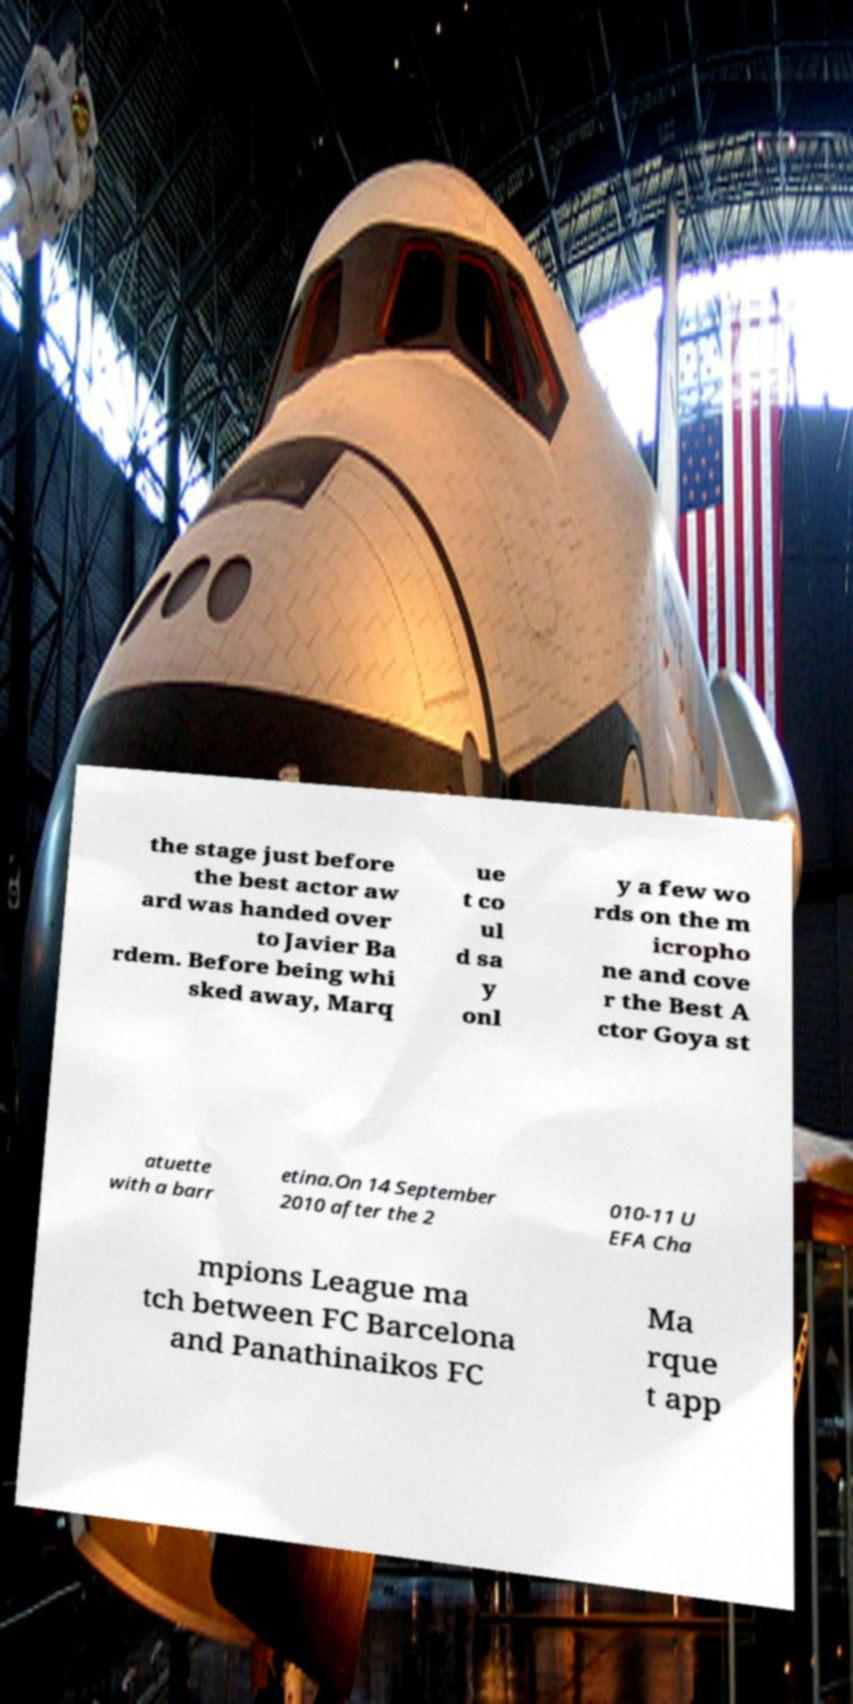Could you extract and type out the text from this image? the stage just before the best actor aw ard was handed over to Javier Ba rdem. Before being whi sked away, Marq ue t co ul d sa y onl y a few wo rds on the m icropho ne and cove r the Best A ctor Goya st atuette with a barr etina.On 14 September 2010 after the 2 010-11 U EFA Cha mpions League ma tch between FC Barcelona and Panathinaikos FC Ma rque t app 